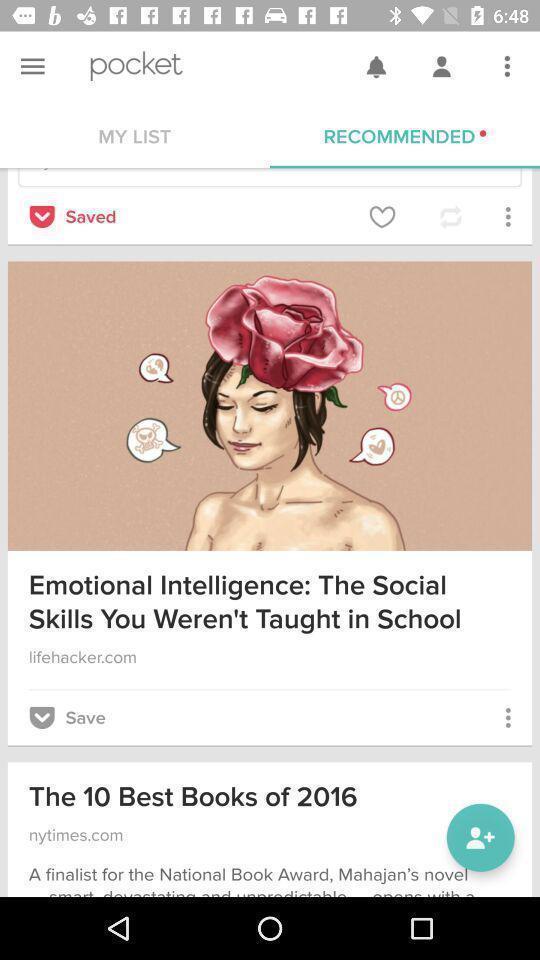Tell me about the visual elements in this screen capture. Screen page displaying various articles. 